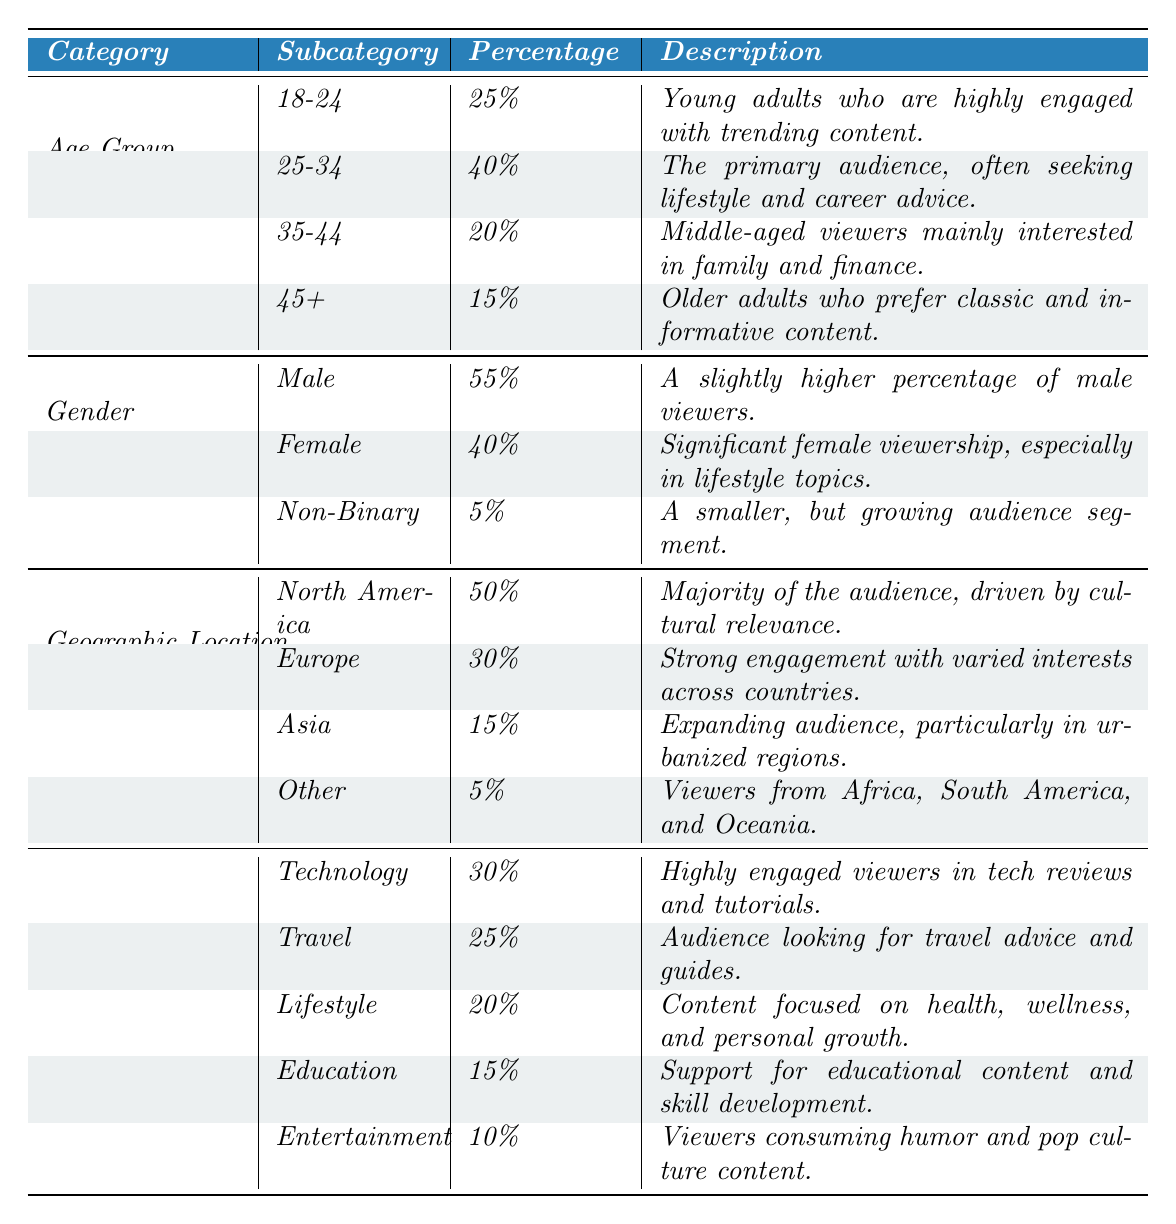What percentage of the audience is aged 25-34? In the Age Group category, the age range of 25-34 has a percentage of 40%.
Answer: 40% Which gender has the highest percentage of viewers? In the Gender category, "Male" has the highest percentage at 55%.
Answer: Male What is the percentage of viewers interested in Entertainment? In the Interests category, "Entertainment" has a percentage of 10%.
Answer: 10% How many age groups have a percentage of 20% or more? The age groups with 20% or more are 18-24 (25%), 25-34 (40%), and 35-44 (20%). This results in a total of 3 age groups.
Answer: 3 What is the difference in percentage between Male and Female viewers? Male viewers make up 55%, and Female viewers make up 40%. The difference is 55% - 40% = 15%.
Answer: 15% Is the audience more predominantly from North America compared to Europe? North America has 50% of the audience, while Europe has 30%, which confirms North America is more predominantly represented.
Answer: Yes What is the total percentage of viewers interested in Technology and Travel combined? The percentage for Technology is 30% and for Travel is 25%. Combined, they total 30% + 25% = 55%.
Answer: 55% Which age group has the least percentage of viewers? In the Age Group category, the 45+ age group has the least percentage at 15%.
Answer: 15% What percentage of the audience is from regions other than North America and Europe? The audience from Asia is 15% and from Other is 5%. Therefore, combining these gives 15% + 5% = 20%.
Answer: 20% Are there more viewers in the 18-24 age group compared to those interested in Education? The 18-24 age group has 25%, while Education has 15%, which means there are more viewers in the 18-24 age group.
Answer: Yes 